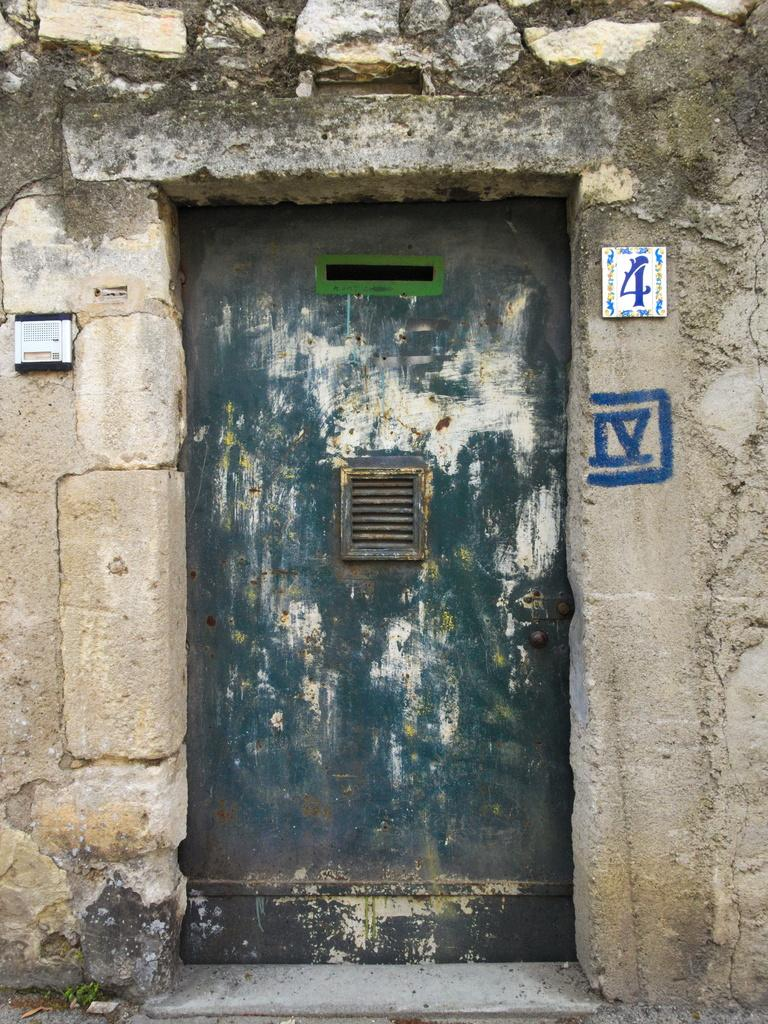What is the main object in the image? There is a door in the image. Is the door connected to any other structure? Yes, the door is attached to a wall. What type of reaction does the scarecrow have when it sees the door in the image? There is no scarecrow present in the image, so it cannot have a reaction to the door. 